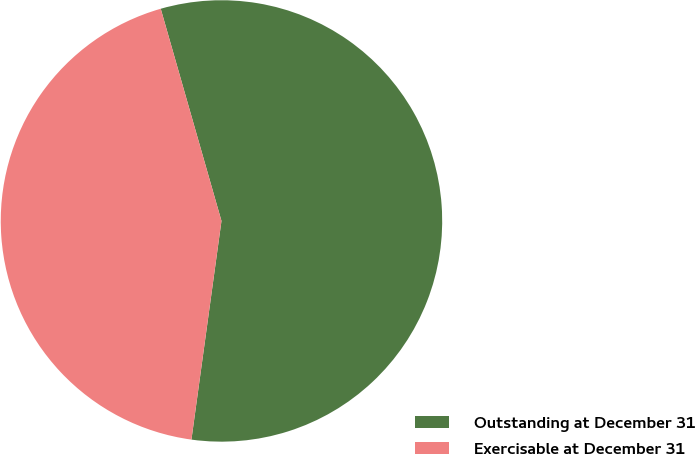Convert chart. <chart><loc_0><loc_0><loc_500><loc_500><pie_chart><fcel>Outstanding at December 31<fcel>Exercisable at December 31<nl><fcel>56.61%<fcel>43.39%<nl></chart> 